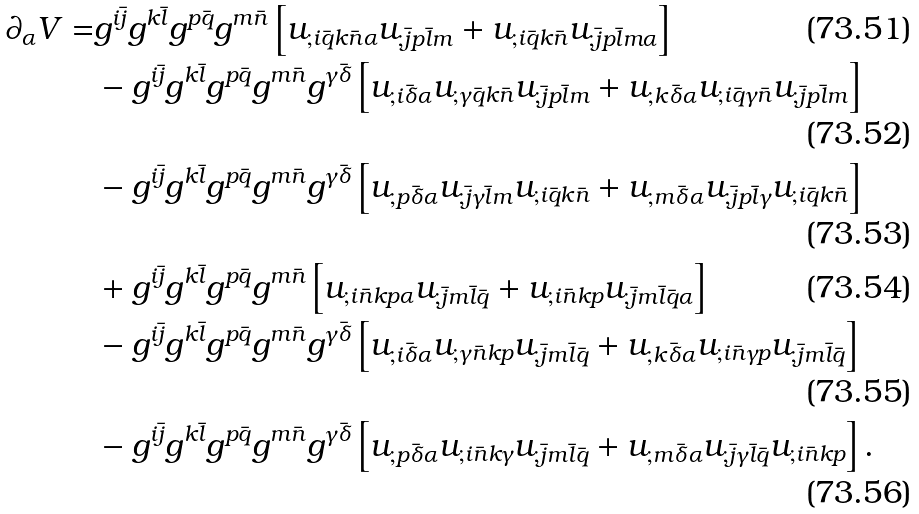<formula> <loc_0><loc_0><loc_500><loc_500>\partial _ { \alpha } V = & g ^ { i \bar { j } } g ^ { k \bar { l } } g ^ { p \bar { q } } g ^ { m \bar { n } } \left [ u _ { ; i \bar { q } k \bar { n } \alpha } u _ { ; \bar { j } p \bar { l } m } + u _ { ; i \bar { q } k \bar { n } } u _ { ; \bar { j } p \bar { l } m \alpha } \right ] \\ & - g ^ { i \bar { j } } g ^ { k \bar { l } } g ^ { p \bar { q } } g ^ { m \bar { n } } g ^ { \gamma \bar { \delta } } \left [ u _ { ; i \bar { \delta } \alpha } u _ { ; \gamma \bar { q } k \bar { n } } u _ { ; \bar { j } p \bar { l } m } + u _ { ; k \bar { \delta } \alpha } u _ { ; i \bar { q } \gamma \bar { n } } u _ { ; \bar { j } p \bar { l } m } \right ] \\ & - g ^ { i \bar { j } } g ^ { k \bar { l } } g ^ { p \bar { q } } g ^ { m \bar { n } } g ^ { \gamma \bar { \delta } } \left [ u _ { ; p \bar { \delta } \alpha } u _ { ; \bar { j } \gamma \bar { l } m } u _ { ; i \bar { q } k \bar { n } } + u _ { ; m \bar { \delta } \alpha } u _ { ; \bar { j } p \bar { l } \gamma } u _ { ; i \bar { q } k \bar { n } } \right ] \\ & + g ^ { i \bar { j } } g ^ { k \bar { l } } g ^ { p \bar { q } } g ^ { m \bar { n } } \left [ u _ { ; i \bar { n } k p \alpha } u _ { ; \bar { j } m \bar { l } \bar { q } } + u _ { ; i \bar { n } k p } u _ { ; \bar { j } m \bar { l } \bar { q } \alpha } \right ] \\ & - g ^ { i \bar { j } } g ^ { k \bar { l } } g ^ { p \bar { q } } g ^ { m \bar { n } } g ^ { \gamma \bar { \delta } } \left [ u _ { ; i \bar { \delta } \alpha } u _ { ; \gamma \bar { n } k p } u _ { ; \bar { j } m \bar { l } \bar { q } } + u _ { ; k \bar { \delta } \alpha } u _ { ; i \bar { n } \gamma p } u _ { ; \bar { j } m \bar { l } \bar { q } } \right ] \\ & - g ^ { i \bar { j } } g ^ { k \bar { l } } g ^ { p \bar { q } } g ^ { m \bar { n } } g ^ { \gamma \bar { \delta } } \left [ u _ { ; p \bar { \delta } \alpha } u _ { ; i \bar { n } k \gamma } u _ { ; \bar { j } m \bar { l } \bar { q } } + u _ { ; m \bar { \delta } \alpha } u _ { ; \bar { j } \gamma \bar { l } \bar { q } } u _ { ; i \bar { n } k p } \right ] .</formula> 